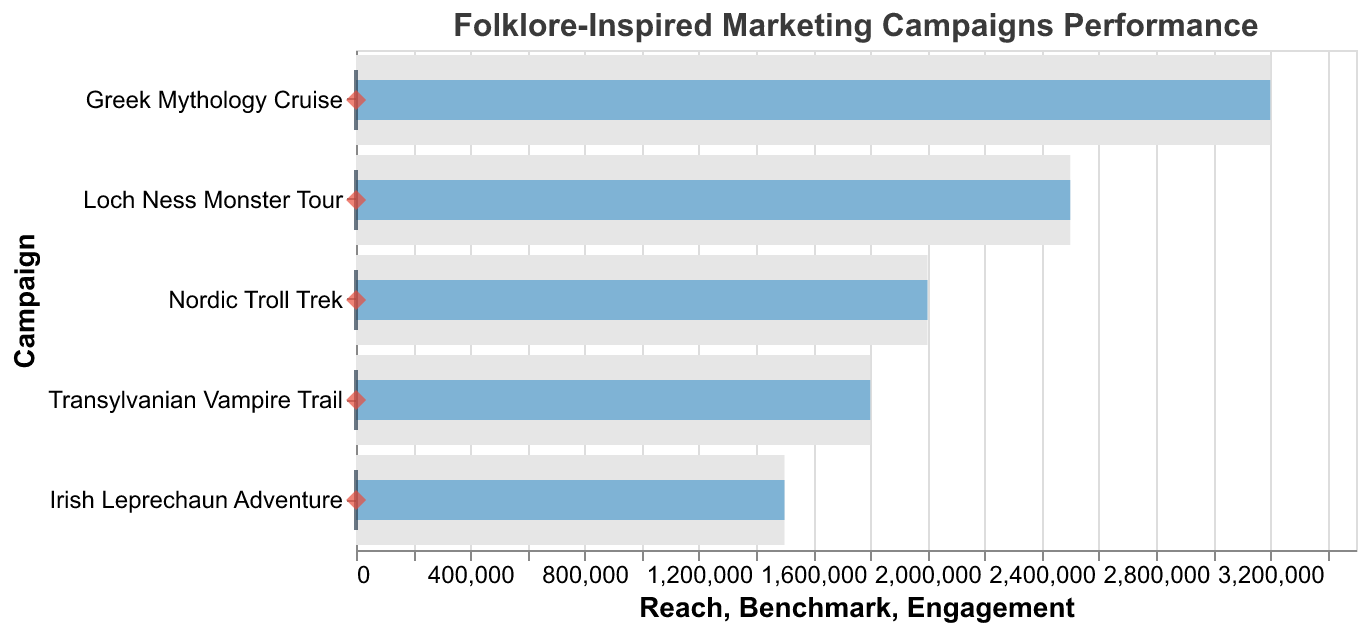What's the title of the figure? The title of the figure is found at the top, which states "Folklore-Inspired Marketing Campaigns Performance".
Answer: Folklore-Inspired Marketing Campaigns Performance How many campaigns are displayed in the figure? The figure shows bars representing each campaign. Counting these bars gives us the number of campaigns: Loch Ness Monster Tour, Transylvanian Vampire Trail, Greek Mythology Cruise, Irish Leprechaun Adventure, Nordic Troll Trek.
Answer: 5 Which campaign has the highest social media reach? By inspecting the lengths of the bars representing reach, the Greek Mythology Cruise bar is the longest, indicating the highest reach.
Answer: Greek Mythology Cruise Which campaign has the lowest engagement rate? The engagement rates are indicated by red diamond points. The engagement rate for Nordic Troll Trek is lowest at 3.9.
Answer: Nordic Troll Trek What is the engagement rate of the Irish Leprechaun Adventure campaign? Find the red diamond point corresponding to the Irish Leprechaun Adventure and check its position on the x-axis. The engagement rate is 4.7.
Answer: 4.7 How does the engagement rate of "Greek Mythology Cruise" compare to the benchmark? The engagement rate and the benchmark are indicated by the red diamond and the blue tick mark respectively. The engagement rate for Greek Mythology Cruise (5.1) is above the benchmark (3.5).
Answer: Above Which campaigns have a higher engagement rate than the benchmark? Comparing the red diamond points (engagement rates) to the blue tick mark (benchmark), the campaigns with higher engagement rates are Loch Ness Monster Tour, Greek Mythology Cruise, Irish Leprechaun Adventure, and Nordic Troll Trek.
Answer: 4 campaigns What is the reach difference between the "Loch Ness Monster Tour" and "Transylvanian Vampire Trail"? The reach difference is the length difference of the bars. Loch Ness Monster Tour has a reach of 2,500,000 and Transylvanian Vampire Trail of 1,800,000. The difference is 2,500,000 - 1,800,000.
Answer: 700,000 Which campaign has the closest engagement rate to the benchmark? Compare the engagement rates (red diamond points) to the benchmark (blue tick mark). The closest engagement rate to the benchmark is 3.8 from Transylvanian Vampire Trail, where the benchmark is 3.5.
Answer: Transylvanian Vampire Trail What is the average engagement rate for all campaigns? Sum all engagement rates and divide by the number of campaigns: (4.2 + 3.8 + 5.1 + 4.7 + 3.9) / 5. The sum is 21.7, so the average is 21.7 / 5.
Answer: 4.34 